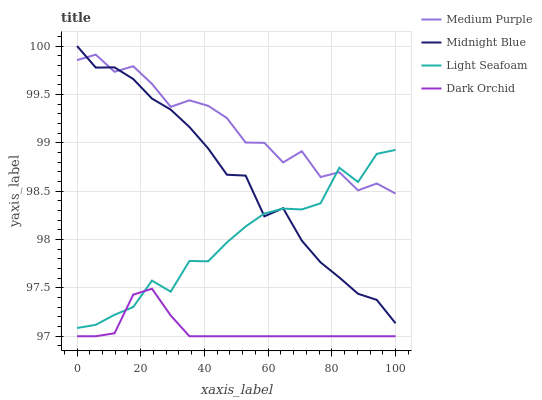Does Dark Orchid have the minimum area under the curve?
Answer yes or no. Yes. Does Medium Purple have the maximum area under the curve?
Answer yes or no. Yes. Does Light Seafoam have the minimum area under the curve?
Answer yes or no. No. Does Light Seafoam have the maximum area under the curve?
Answer yes or no. No. Is Dark Orchid the smoothest?
Answer yes or no. Yes. Is Medium Purple the roughest?
Answer yes or no. Yes. Is Light Seafoam the smoothest?
Answer yes or no. No. Is Light Seafoam the roughest?
Answer yes or no. No. Does Dark Orchid have the lowest value?
Answer yes or no. Yes. Does Light Seafoam have the lowest value?
Answer yes or no. No. Does Midnight Blue have the highest value?
Answer yes or no. Yes. Does Light Seafoam have the highest value?
Answer yes or no. No. Is Dark Orchid less than Midnight Blue?
Answer yes or no. Yes. Is Medium Purple greater than Dark Orchid?
Answer yes or no. Yes. Does Midnight Blue intersect Medium Purple?
Answer yes or no. Yes. Is Midnight Blue less than Medium Purple?
Answer yes or no. No. Is Midnight Blue greater than Medium Purple?
Answer yes or no. No. Does Dark Orchid intersect Midnight Blue?
Answer yes or no. No. 